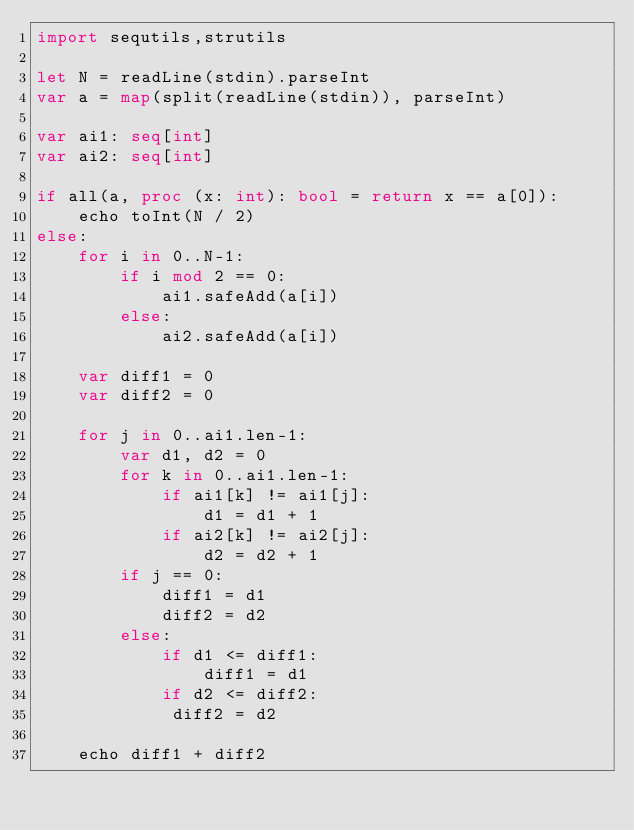Convert code to text. <code><loc_0><loc_0><loc_500><loc_500><_Nim_>import sequtils,strutils

let N = readLine(stdin).parseInt
var a = map(split(readLine(stdin)), parseInt)

var ai1: seq[int]
var ai2: seq[int]

if all(a, proc (x: int): bool = return x == a[0]):
    echo toInt(N / 2)
else:
    for i in 0..N-1:
        if i mod 2 == 0:
            ai1.safeAdd(a[i])
        else:
            ai2.safeAdd(a[i])

    var diff1 = 0
    var diff2 = 0

    for j in 0..ai1.len-1:
        var d1, d2 = 0
        for k in 0..ai1.len-1:
            if ai1[k] != ai1[j]:
                d1 = d1 + 1
            if ai2[k] != ai2[j]:
                d2 = d2 + 1
        if j == 0:
            diff1 = d1
            diff2 = d2
        else:
            if d1 <= diff1:
                diff1 = d1
            if d2 <= diff2:
             diff2 = d2
        
    echo diff1 + diff2</code> 